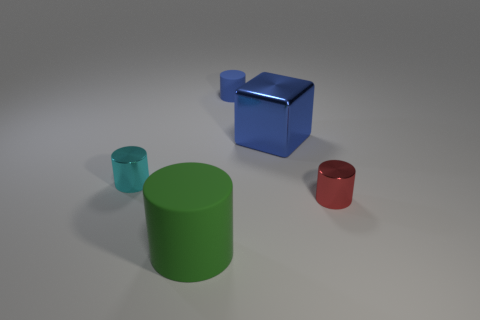Do these objects represent something symbolic? While there's no clear indication of symbolism inherent to the objects themselves, one could interpret them as a simple representation of shapes and colors used in educational materials, or as generic placeholders in a design or spatial arrangement concept. 